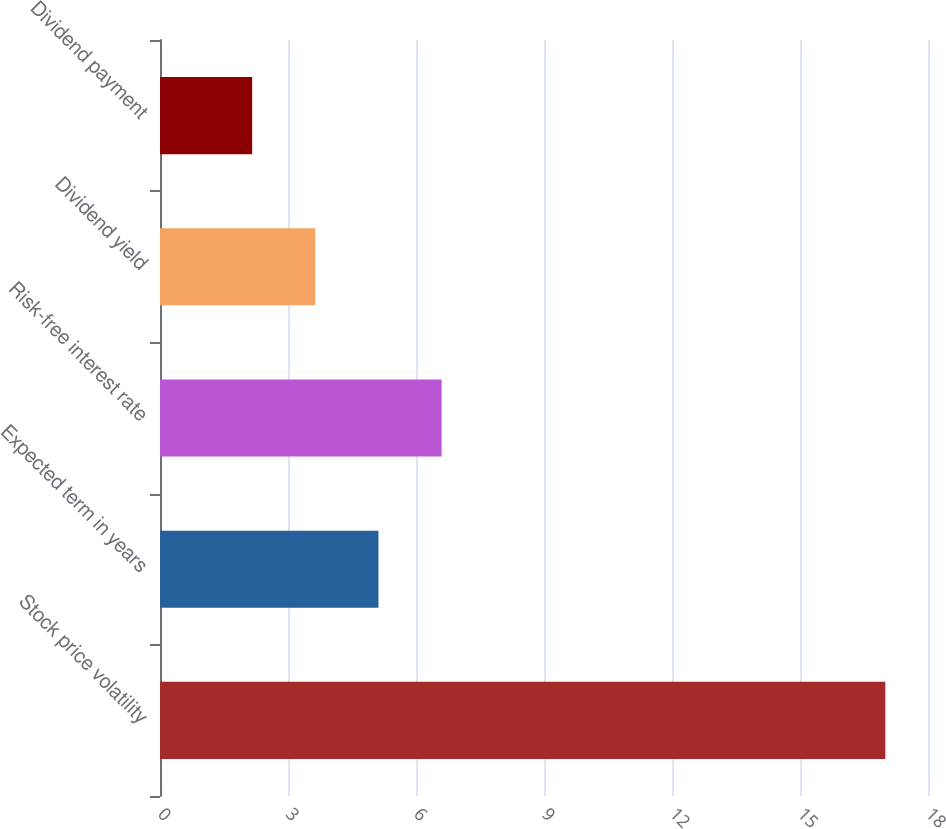<chart> <loc_0><loc_0><loc_500><loc_500><bar_chart><fcel>Stock price volatility<fcel>Expected term in years<fcel>Risk-free interest rate<fcel>Dividend yield<fcel>Dividend payment<nl><fcel>17<fcel>5.12<fcel>6.6<fcel>3.64<fcel>2.16<nl></chart> 